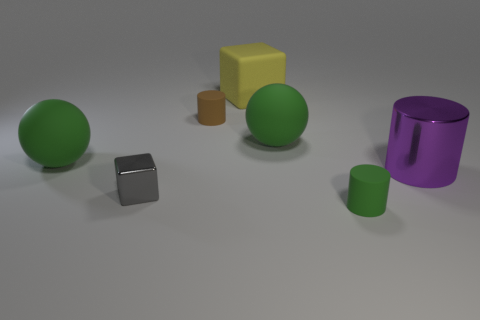How many objects in the image have a flat top? There are three objects in the image that have flat tops. These include the gray cube, the yellow cube, and the larger purple cylinder. 